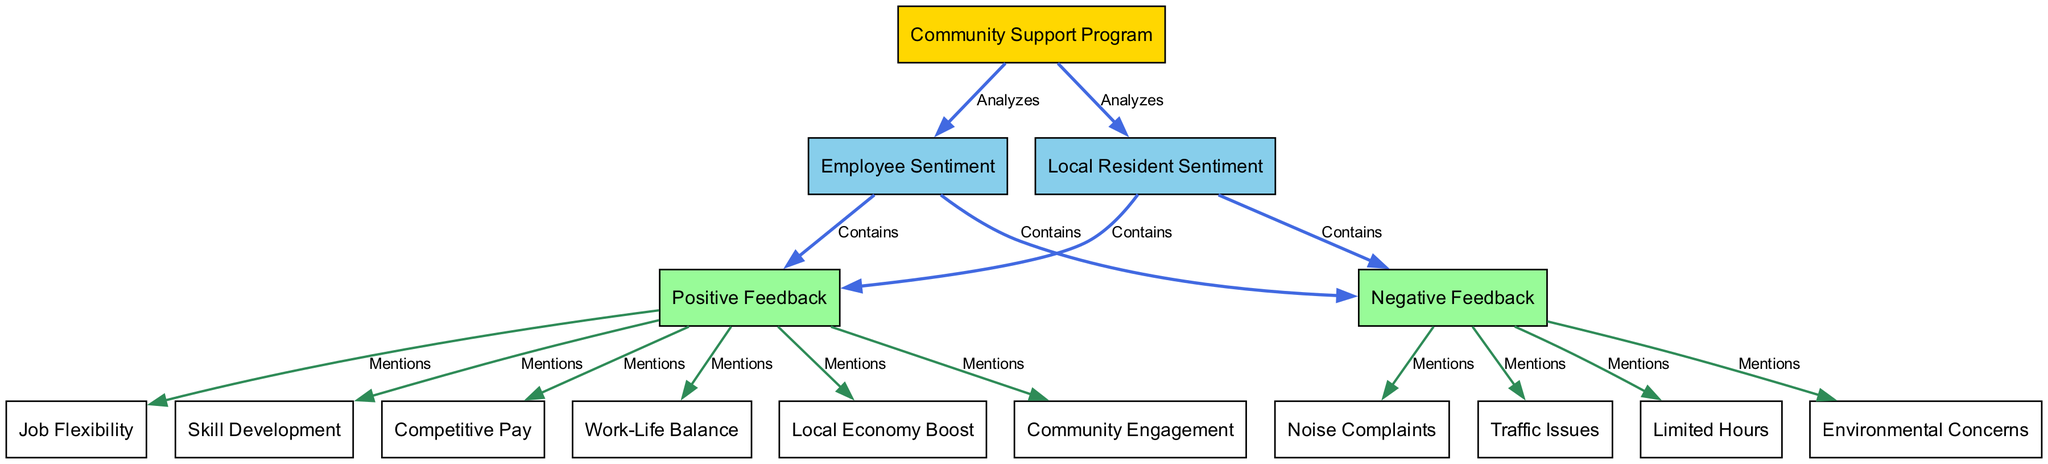What is the total number of nodes in the diagram? There are 15 distinct nodes listed in the data: Community Support Program, Employee Sentiment, Local Resident Sentiment, Positive Feedback, Negative Feedback, Job Flexibility, Skill Development, Competitive Pay, Limited Hours, Work-Life Balance, Local Economy Boost, Community Engagement, Environmental Concerns, Noise Complaints, and Traffic Issues.
Answer: 15 Which node is connected to both Employee Sentiment and Local Resident Sentiment? The node "Community Support Program" is the only node that connects to both Employee Sentiment and Local Resident Sentiment, as indicated by the edges originating from it to these nodes.
Answer: Community Support Program What type of feedback does "Negative Feedback" mention the most? The "Negative Feedback" node mentions "Limited Hours," "Environmental Concerns," "Noise Complaints," and "Traffic Issues," but the one it mentions is "Limited Hours" based on the edges leading from it.
Answer: Limited Hours How many edges are connected to the "Positive Feedback" node? The "Positive Feedback" node has six edges connecting it to the nodes: Job Flexibility, Skill Development, Competitive Pay, Work-Life Balance, Local Economy Boost, and Community Engagement.
Answer: 6 What are the two types of sentiments represented in the diagram? The diagram clearly depicts two types of sentiments: "Employee Sentiment" and "Local Resident Sentiment," both of which are analyzed under the "Community Support Program."
Answer: Employee Sentiment and Local Resident Sentiment Which node has the most mentions in "Positive Feedback"? The node "Community Engagement" is among the mentions from "Positive Feedback," which also includes Job Flexibility, Skill Development, Competitive Pay, Work-Life Balance, and Local Economy Boost. However, no specific count for mentions is clarified in the data beyond the connection through edges.
Answer: Community Engagement What is the primary focus of the "Community Support Program"? The diagram indicates the "Community Support Program" analyzes sentiments from both employees and local residents, thus its primary focus revolves around understanding community feedback regarding part-time jobs.
Answer: Analyzing sentiments 